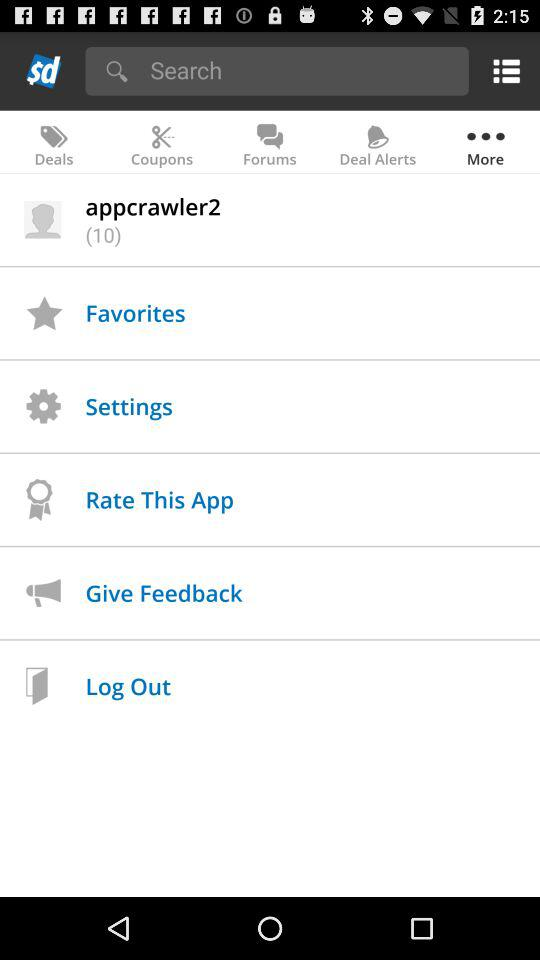What is the total count of "appcrawler2"? The total count is 10. 